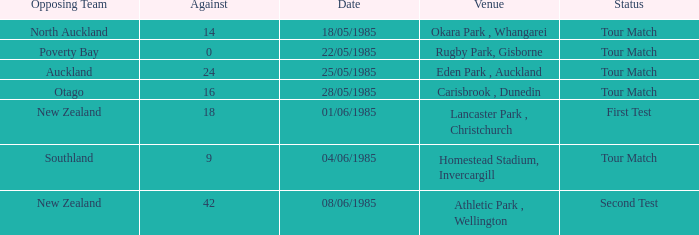Which opposing team had an Against score less than 42 and a Tour Match status in Rugby Park, Gisborne? Poverty Bay. 